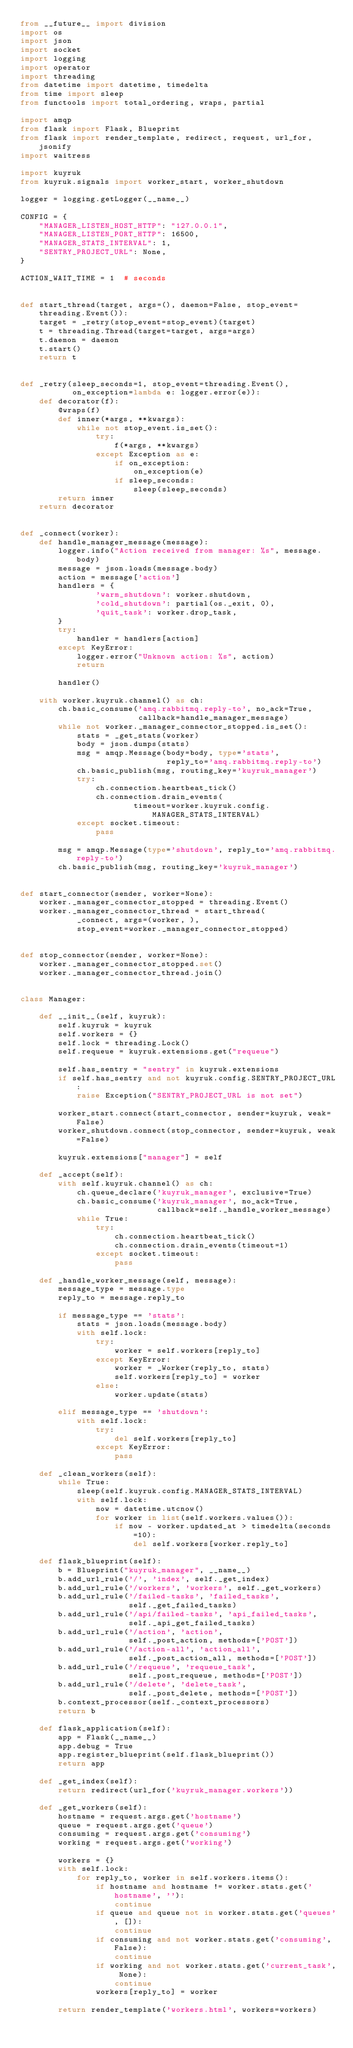<code> <loc_0><loc_0><loc_500><loc_500><_Python_>from __future__ import division
import os
import json
import socket
import logging
import operator
import threading
from datetime import datetime, timedelta
from time import sleep
from functools import total_ordering, wraps, partial

import amqp
from flask import Flask, Blueprint
from flask import render_template, redirect, request, url_for, jsonify
import waitress

import kuyruk
from kuyruk.signals import worker_start, worker_shutdown

logger = logging.getLogger(__name__)

CONFIG = {
    "MANAGER_LISTEN_HOST_HTTP": "127.0.0.1",
    "MANAGER_LISTEN_PORT_HTTP": 16500,
    "MANAGER_STATS_INTERVAL": 1,
    "SENTRY_PROJECT_URL": None,
}

ACTION_WAIT_TIME = 1  # seconds


def start_thread(target, args=(), daemon=False, stop_event=threading.Event()):
    target = _retry(stop_event=stop_event)(target)
    t = threading.Thread(target=target, args=args)
    t.daemon = daemon
    t.start()
    return t


def _retry(sleep_seconds=1, stop_event=threading.Event(),
           on_exception=lambda e: logger.error(e)):
    def decorator(f):
        @wraps(f)
        def inner(*args, **kwargs):
            while not stop_event.is_set():
                try:
                    f(*args, **kwargs)
                except Exception as e:
                    if on_exception:
                        on_exception(e)
                    if sleep_seconds:
                        sleep(sleep_seconds)
        return inner
    return decorator


def _connect(worker):
    def handle_manager_message(message):
        logger.info("Action received from manager: %s", message.body)
        message = json.loads(message.body)
        action = message['action']
        handlers = {
                'warm_shutdown': worker.shutdown,
                'cold_shutdown': partial(os._exit, 0),
                'quit_task': worker.drop_task,
        }
        try:
            handler = handlers[action]
        except KeyError:
            logger.error("Unknown action: %s", action)
            return

        handler()

    with worker.kuyruk.channel() as ch:
        ch.basic_consume('amq.rabbitmq.reply-to', no_ack=True,
                         callback=handle_manager_message)
        while not worker._manager_connector_stopped.is_set():
            stats = _get_stats(worker)
            body = json.dumps(stats)
            msg = amqp.Message(body=body, type='stats',
                               reply_to='amq.rabbitmq.reply-to')
            ch.basic_publish(msg, routing_key='kuyruk_manager')
            try:
                ch.connection.heartbeat_tick()
                ch.connection.drain_events(
                        timeout=worker.kuyruk.config.MANAGER_STATS_INTERVAL)
            except socket.timeout:
                pass

        msg = amqp.Message(type='shutdown', reply_to='amq.rabbitmq.reply-to')
        ch.basic_publish(msg, routing_key='kuyruk_manager')


def start_connector(sender, worker=None):
    worker._manager_connector_stopped = threading.Event()
    worker._manager_connector_thread = start_thread(
            _connect, args=(worker, ),
            stop_event=worker._manager_connector_stopped)


def stop_connector(sender, worker=None):
    worker._manager_connector_stopped.set()
    worker._manager_connector_thread.join()


class Manager:

    def __init__(self, kuyruk):
        self.kuyruk = kuyruk
        self.workers = {}
        self.lock = threading.Lock()
        self.requeue = kuyruk.extensions.get("requeue")

        self.has_sentry = "sentry" in kuyruk.extensions
        if self.has_sentry and not kuyruk.config.SENTRY_PROJECT_URL:
            raise Exception("SENTRY_PROJECT_URL is not set")

        worker_start.connect(start_connector, sender=kuyruk, weak=False)
        worker_shutdown.connect(stop_connector, sender=kuyruk, weak=False)

        kuyruk.extensions["manager"] = self

    def _accept(self):
        with self.kuyruk.channel() as ch:
            ch.queue_declare('kuyruk_manager', exclusive=True)
            ch.basic_consume('kuyruk_manager', no_ack=True,
                             callback=self._handle_worker_message)
            while True:
                try:
                    ch.connection.heartbeat_tick()
                    ch.connection.drain_events(timeout=1)
                except socket.timeout:
                    pass

    def _handle_worker_message(self, message):
        message_type = message.type
        reply_to = message.reply_to

        if message_type == 'stats':
            stats = json.loads(message.body)
            with self.lock:
                try:
                    worker = self.workers[reply_to]
                except KeyError:
                    worker = _Worker(reply_to, stats)
                    self.workers[reply_to] = worker
                else:
                    worker.update(stats)

        elif message_type == 'shutdown':
            with self.lock:
                try:
                    del self.workers[reply_to]
                except KeyError:
                    pass

    def _clean_workers(self):
        while True:
            sleep(self.kuyruk.config.MANAGER_STATS_INTERVAL)
            with self.lock:
                now = datetime.utcnow()
                for worker in list(self.workers.values()):
                    if now - worker.updated_at > timedelta(seconds=10):
                        del self.workers[worker.reply_to]

    def flask_blueprint(self):
        b = Blueprint("kuyruk_manager", __name__)
        b.add_url_rule('/', 'index', self._get_index)
        b.add_url_rule('/workers', 'workers', self._get_workers)
        b.add_url_rule('/failed-tasks', 'failed_tasks',
                       self._get_failed_tasks)
        b.add_url_rule('/api/failed-tasks', 'api_failed_tasks',
                       self._api_get_failed_tasks)
        b.add_url_rule('/action', 'action',
                       self._post_action, methods=['POST'])
        b.add_url_rule('/action-all', 'action_all',
                       self._post_action_all, methods=['POST'])
        b.add_url_rule('/requeue', 'requeue_task',
                       self._post_requeue, methods=['POST'])
        b.add_url_rule('/delete', 'delete_task',
                       self._post_delete, methods=['POST'])
        b.context_processor(self._context_processors)
        return b

    def flask_application(self):
        app = Flask(__name__)
        app.debug = True
        app.register_blueprint(self.flask_blueprint())
        return app

    def _get_index(self):
        return redirect(url_for('kuyruk_manager.workers'))

    def _get_workers(self):
        hostname = request.args.get('hostname')
        queue = request.args.get('queue')
        consuming = request.args.get('consuming')
        working = request.args.get('working')

        workers = {}
        with self.lock:
            for reply_to, worker in self.workers.items():
                if hostname and hostname != worker.stats.get('hostname', ''):
                    continue
                if queue and queue not in worker.stats.get('queues', []):
                    continue
                if consuming and not worker.stats.get('consuming', False):
                    continue
                if working and not worker.stats.get('current_task', None):
                    continue
                workers[reply_to] = worker

        return render_template('workers.html', workers=workers)
</code> 